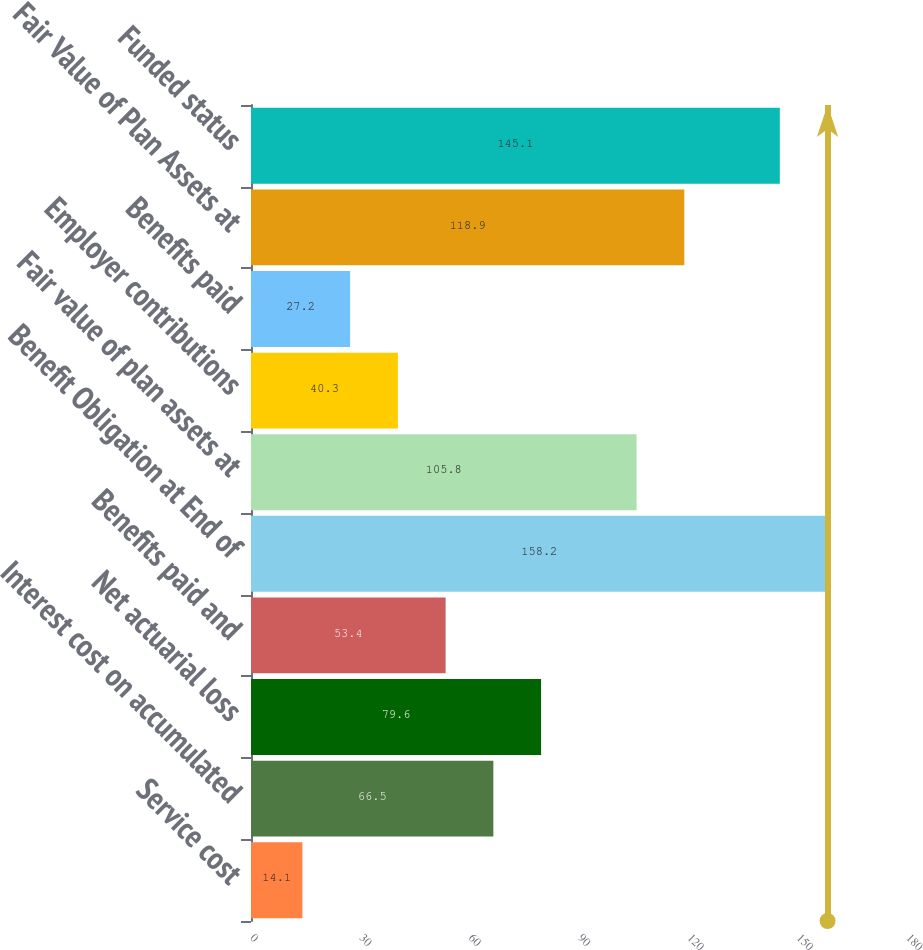Convert chart to OTSL. <chart><loc_0><loc_0><loc_500><loc_500><bar_chart><fcel>Service cost<fcel>Interest cost on accumulated<fcel>Net actuarial loss<fcel>Benefits paid and<fcel>Benefit Obligation at End of<fcel>Fair value of plan assets at<fcel>Employer contributions<fcel>Benefits paid<fcel>Fair Value of Plan Assets at<fcel>Funded status<nl><fcel>14.1<fcel>66.5<fcel>79.6<fcel>53.4<fcel>158.2<fcel>105.8<fcel>40.3<fcel>27.2<fcel>118.9<fcel>145.1<nl></chart> 